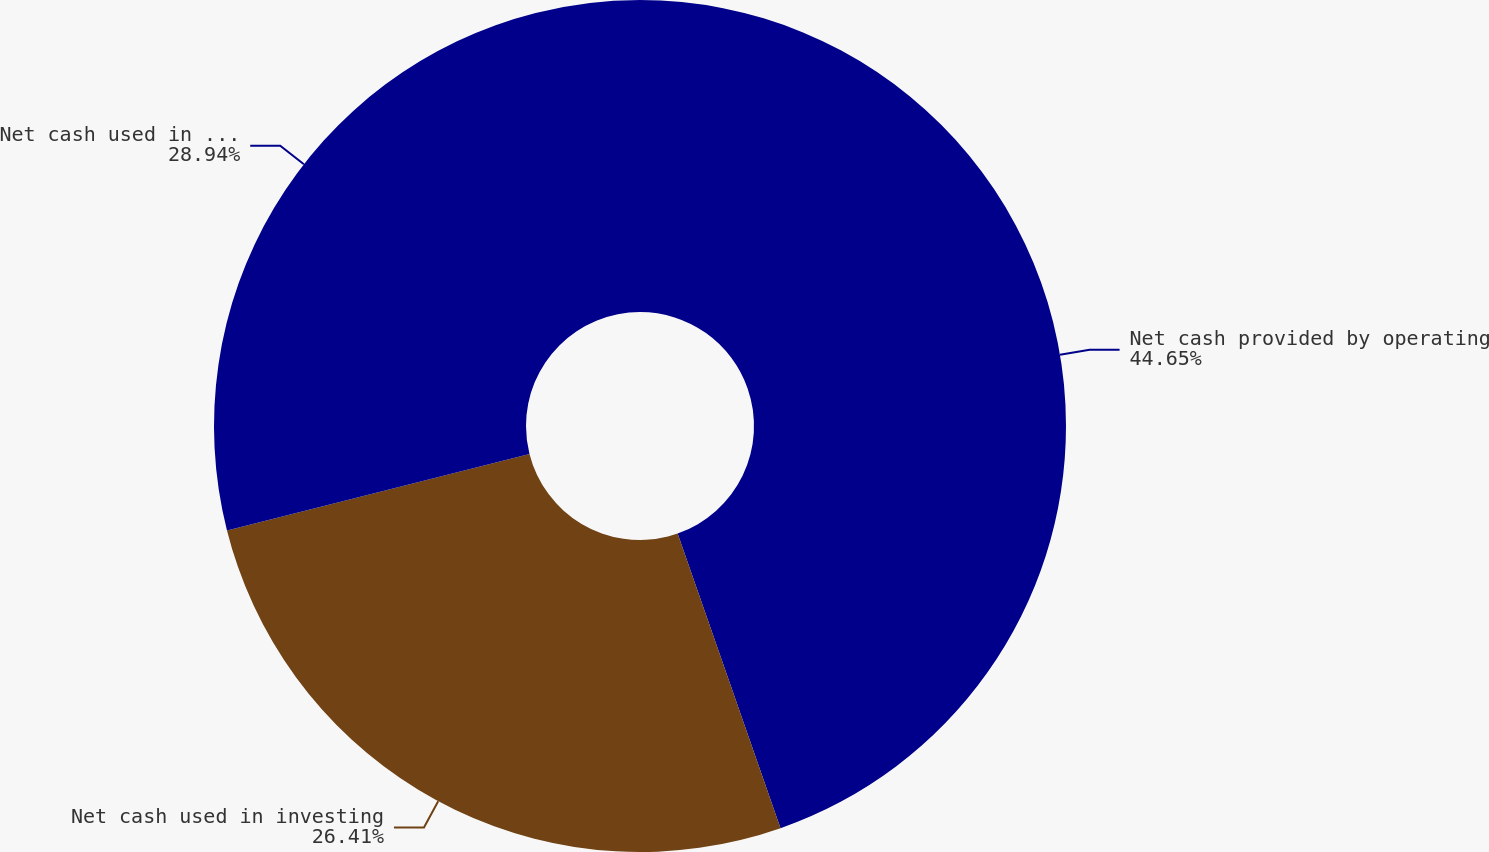Convert chart to OTSL. <chart><loc_0><loc_0><loc_500><loc_500><pie_chart><fcel>Net cash provided by operating<fcel>Net cash used in investing<fcel>Net cash used in financing<nl><fcel>44.65%<fcel>26.41%<fcel>28.94%<nl></chart> 